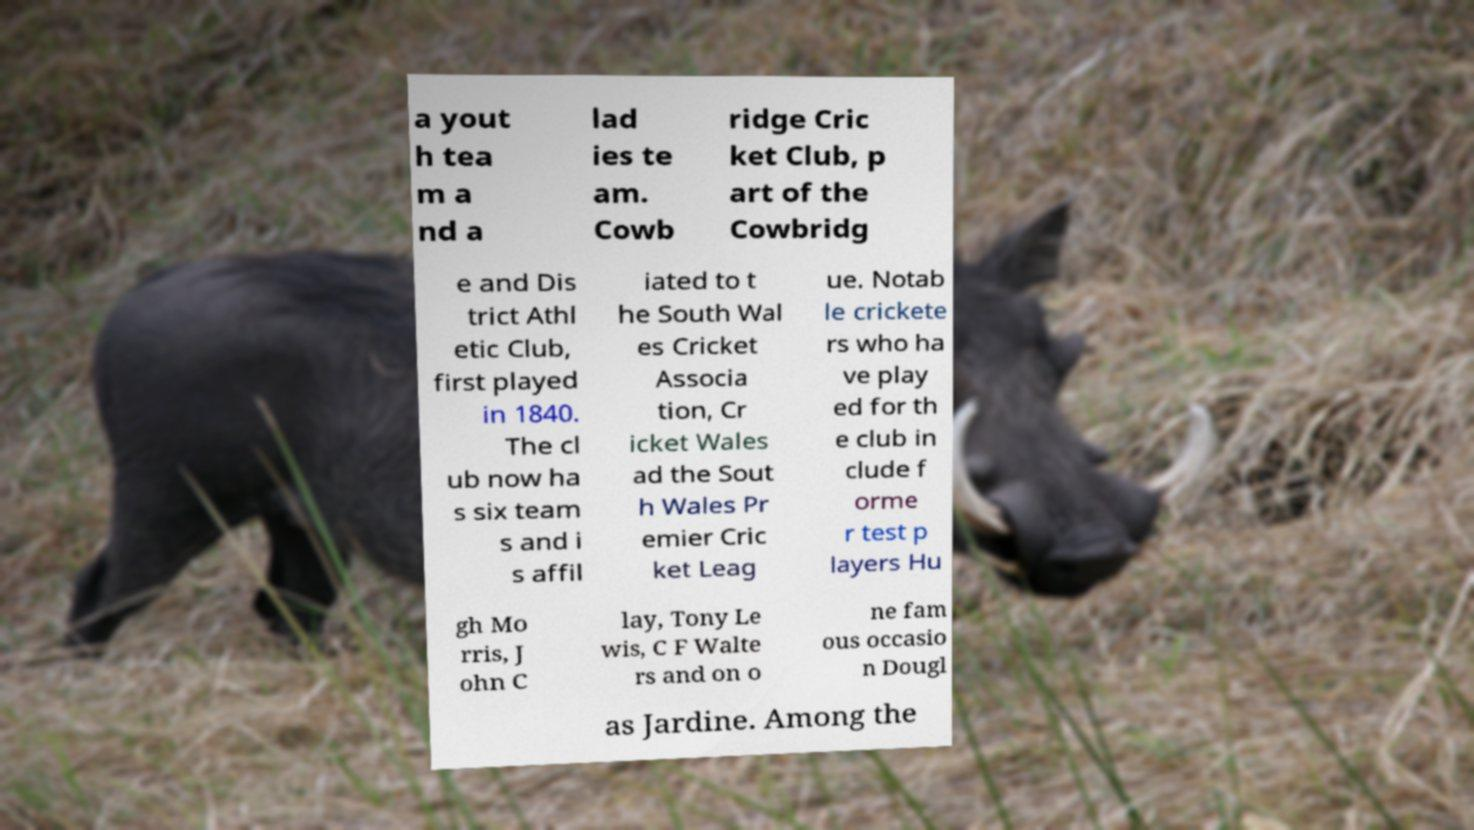Please read and relay the text visible in this image. What does it say? a yout h tea m a nd a lad ies te am. Cowb ridge Cric ket Club, p art of the Cowbridg e and Dis trict Athl etic Club, first played in 1840. The cl ub now ha s six team s and i s affil iated to t he South Wal es Cricket Associa tion, Cr icket Wales ad the Sout h Wales Pr emier Cric ket Leag ue. Notab le crickete rs who ha ve play ed for th e club in clude f orme r test p layers Hu gh Mo rris, J ohn C lay, Tony Le wis, C F Walte rs and on o ne fam ous occasio n Dougl as Jardine. Among the 